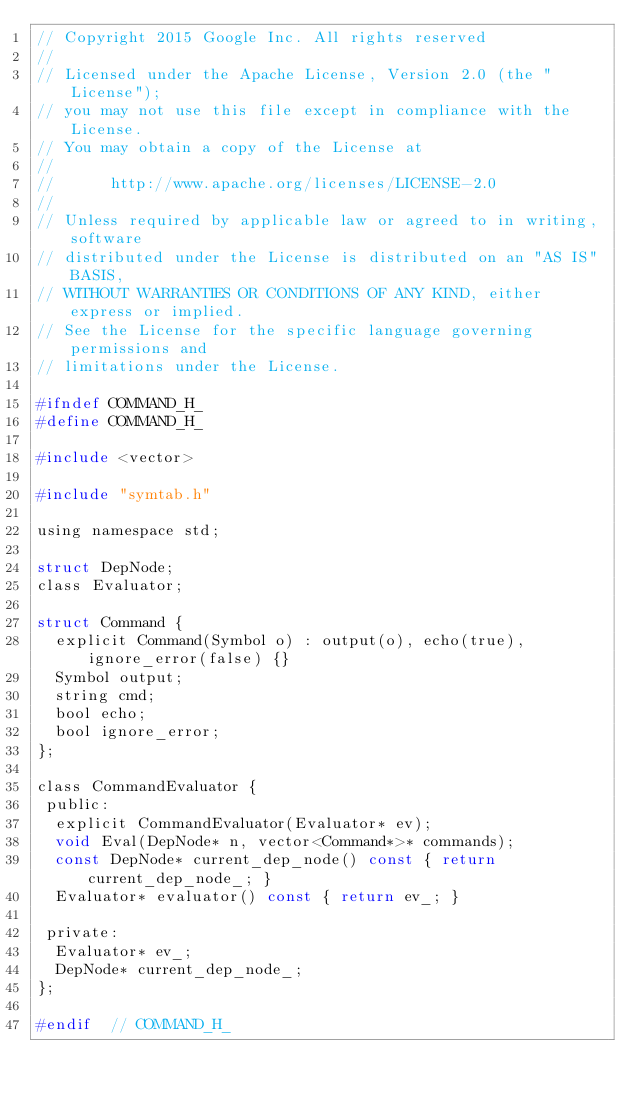Convert code to text. <code><loc_0><loc_0><loc_500><loc_500><_C_>// Copyright 2015 Google Inc. All rights reserved
//
// Licensed under the Apache License, Version 2.0 (the "License");
// you may not use this file except in compliance with the License.
// You may obtain a copy of the License at
//
//      http://www.apache.org/licenses/LICENSE-2.0
//
// Unless required by applicable law or agreed to in writing, software
// distributed under the License is distributed on an "AS IS" BASIS,
// WITHOUT WARRANTIES OR CONDITIONS OF ANY KIND, either express or implied.
// See the License for the specific language governing permissions and
// limitations under the License.

#ifndef COMMAND_H_
#define COMMAND_H_

#include <vector>

#include "symtab.h"

using namespace std;

struct DepNode;
class Evaluator;

struct Command {
  explicit Command(Symbol o) : output(o), echo(true), ignore_error(false) {}
  Symbol output;
  string cmd;
  bool echo;
  bool ignore_error;
};

class CommandEvaluator {
 public:
  explicit CommandEvaluator(Evaluator* ev);
  void Eval(DepNode* n, vector<Command*>* commands);
  const DepNode* current_dep_node() const { return current_dep_node_; }
  Evaluator* evaluator() const { return ev_; }

 private:
  Evaluator* ev_;
  DepNode* current_dep_node_;
};

#endif  // COMMAND_H_
</code> 